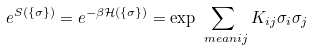Convert formula to latex. <formula><loc_0><loc_0><loc_500><loc_500>e ^ { S ( \{ \sigma \} ) } = e ^ { - \beta \mathcal { H } ( \{ \sigma \} ) } & = \exp \sum _ { \ m e a n { i j } } K _ { i j } \sigma _ { i } \sigma _ { j }</formula> 